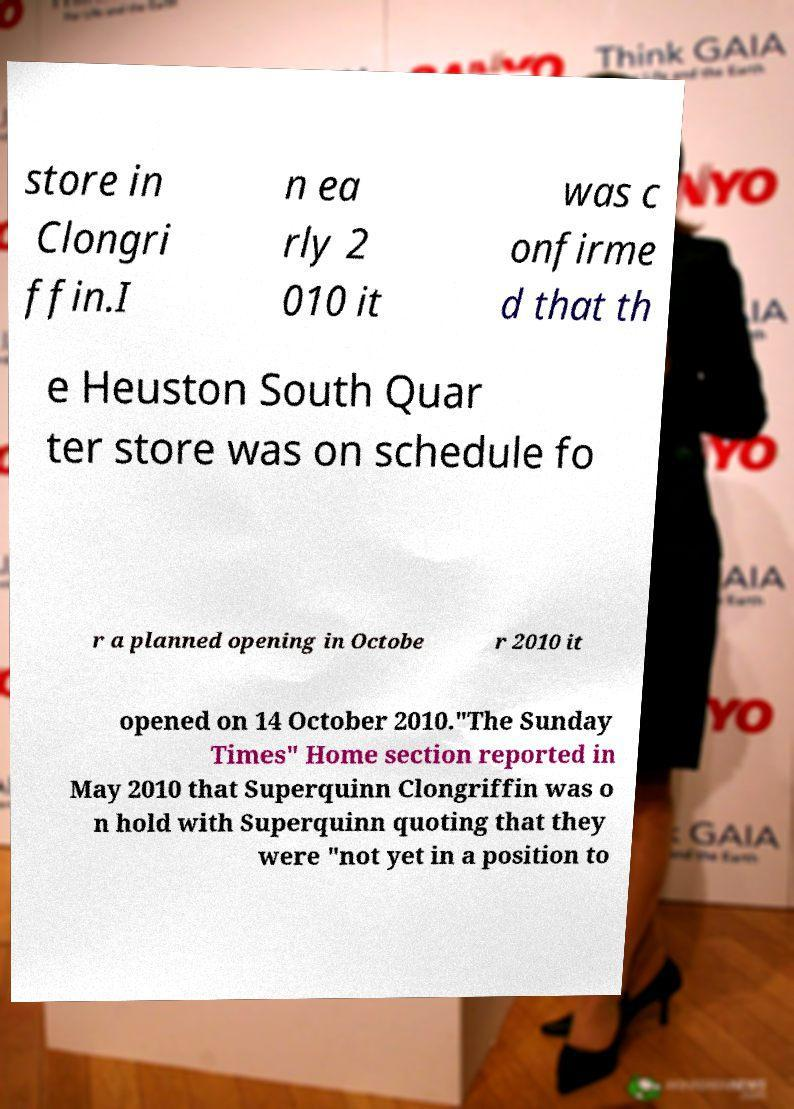Could you assist in decoding the text presented in this image and type it out clearly? store in Clongri ffin.I n ea rly 2 010 it was c onfirme d that th e Heuston South Quar ter store was on schedule fo r a planned opening in Octobe r 2010 it opened on 14 October 2010."The Sunday Times" Home section reported in May 2010 that Superquinn Clongriffin was o n hold with Superquinn quoting that they were "not yet in a position to 